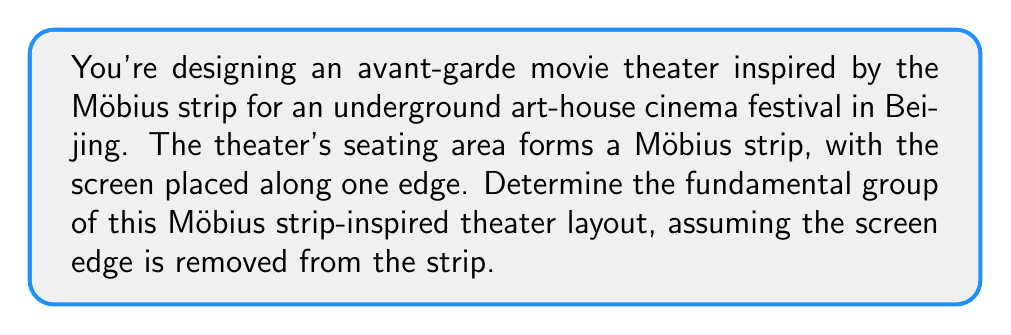Can you solve this math problem? To find the fundamental group of this Möbius strip-inspired theater layout, we'll follow these steps:

1) First, recall that a Möbius strip is a non-orientable surface with one edge and one face.

2) In this case, we're removing the screen edge from the Möbius strip. Topologically, this is equivalent to removing a line segment from the edge of the Möbius strip.

3) When we remove this line segment, the resulting space is homotopy equivalent to a circle. This is because:
   - The Möbius strip deformation retracts to its center circle.
   - Removing a point from this circle (corresponding to the removed edge) results in a space homeomorphic to an open interval.
   - The endpoints of this interval correspond to the endpoints of the removed edge segment, which are identified in the original Möbius strip.

4) Therefore, our space is homotopy equivalent to a circle.

5) The fundamental group of a circle is isomorphic to the integers under addition, denoted as $\mathbb{Z}$.

[asy]
import geometry;

path p = (0,0)--(100,0);
path q = arc((50,0), 50, 0, 180);
path r = (100,0)--(0,0);

draw(p, blue);
draw(q, blue);
draw(r, blue+dashed);

label("Möbius strip", (50,-20));
label("Removed edge (screen)", (50,0), N);
[/asy]

In the diagram, the blue arc represents the Möbius strip after removing the edge (represented by the dashed line). This is homotopy equivalent to a circle.
Answer: The fundamental group of the Möbius strip-inspired theater layout is $\pi_1 \cong \mathbb{Z}$. 